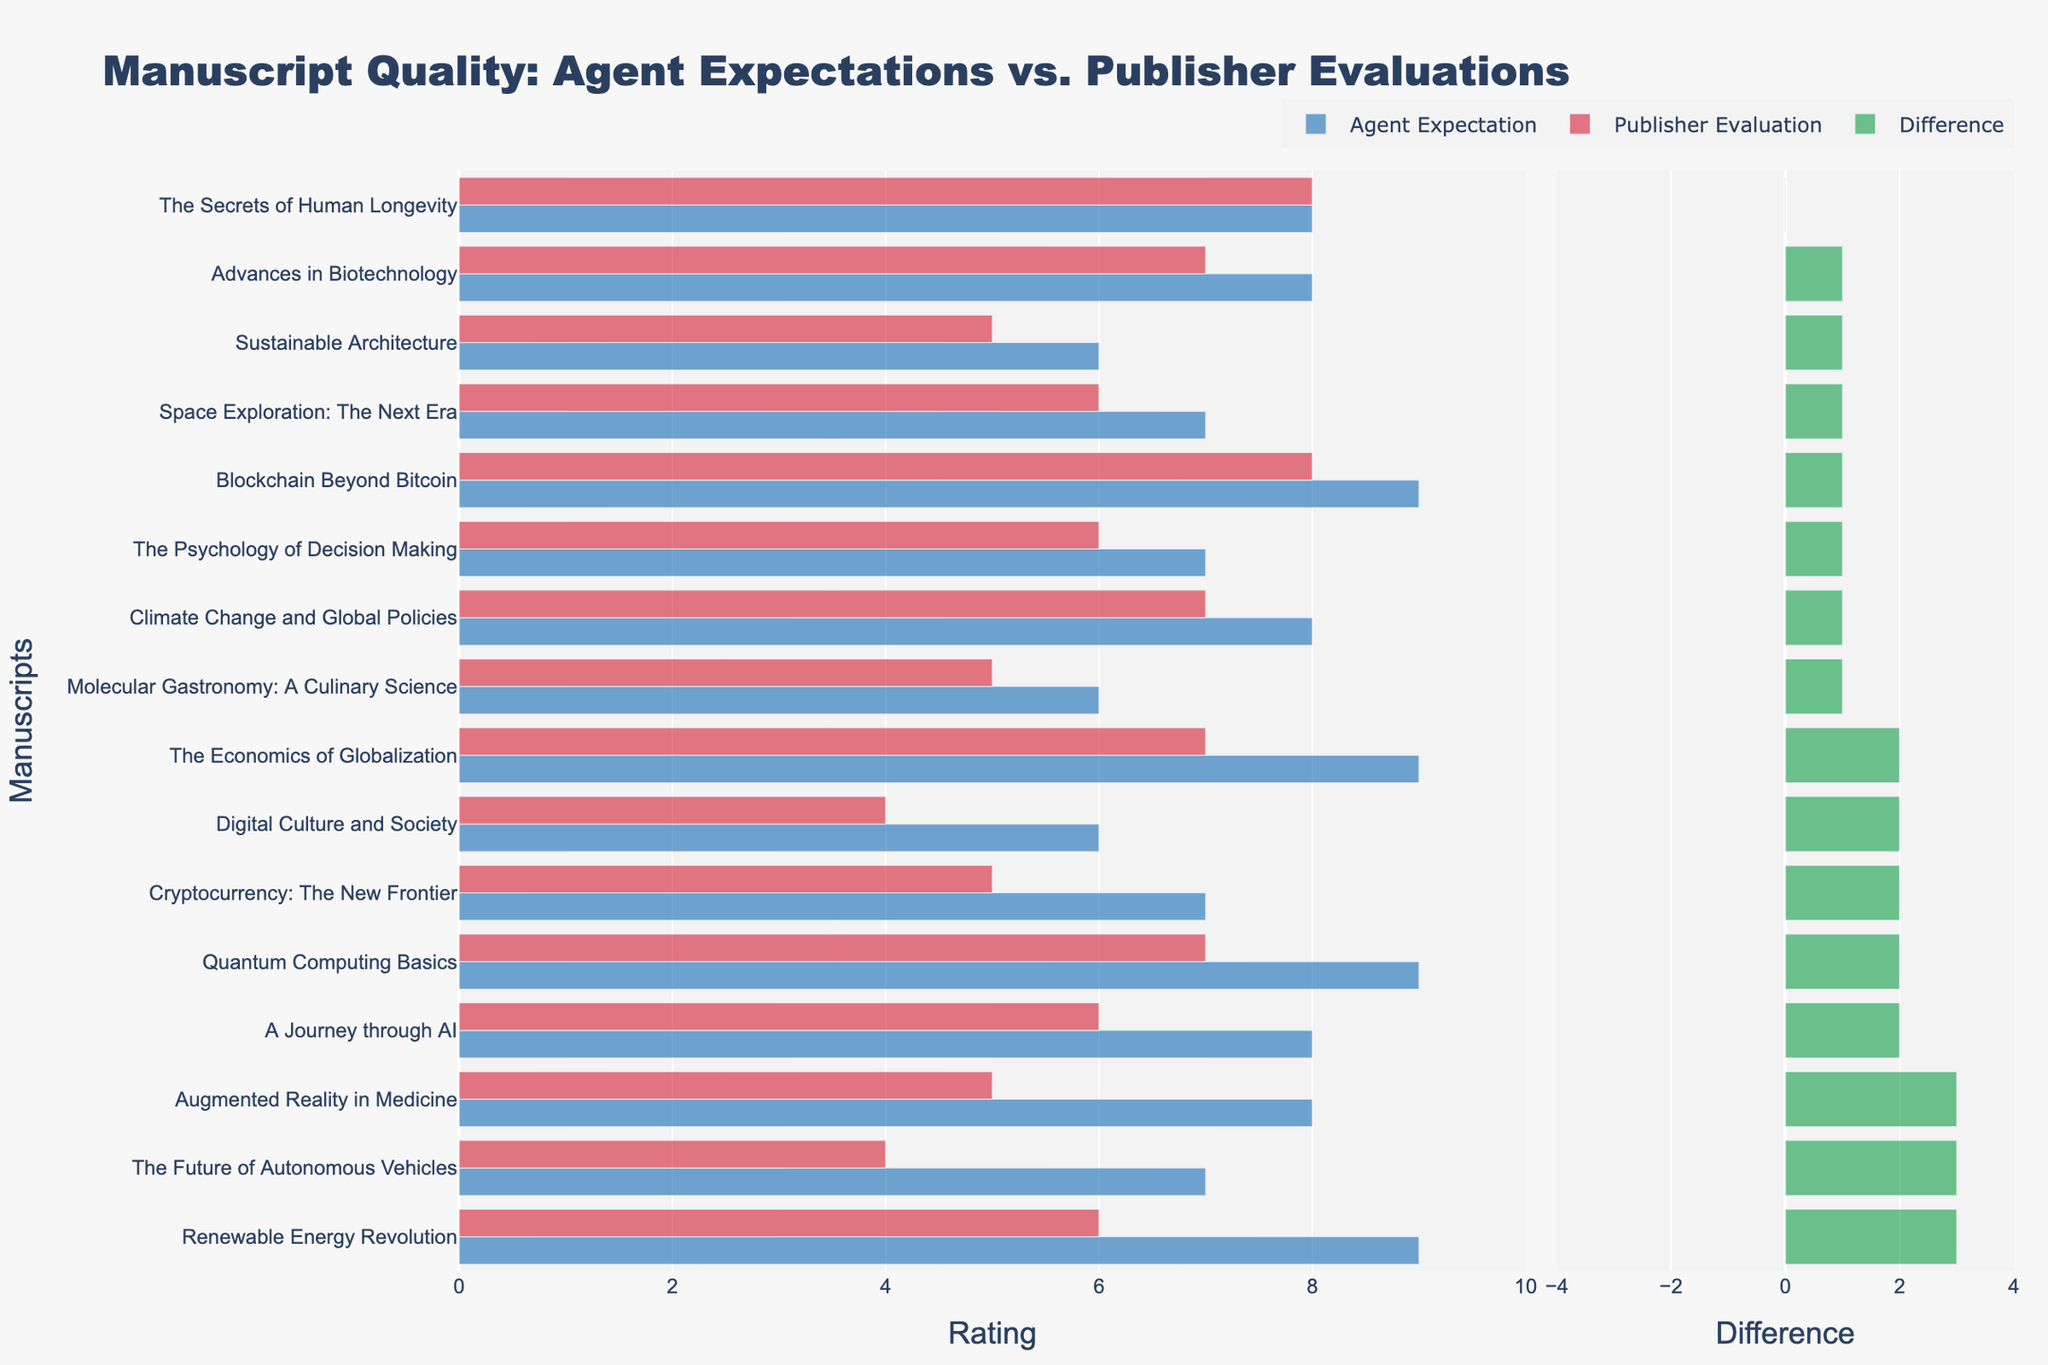What's the difference between the Agent Expectation and Publisher Evaluation for "Renewable Energy Revolution"? Locate the "Renewable Energy Revolution" manuscript on the figure, check the lengths of the bars representing Agent Expectation and Publisher Evaluation. The difference is (9 - 6).
Answer: 3 Which manuscript has the largest discrepancy between Agent Expectation and Publisher Evaluation? Find the manuscript with the longest difference bar (green bar). "The Future of Autonomous Vehicles" shows the largest negative difference.
Answer: "The Future of Autonomous Vehicles" How many manuscripts have Agent Expectations equal to Publisher Evaluations? Look at the figure and count the manuscripts where the blue and red bars have the same length. Only one manuscript, "The Secrets of Human Longevity," has equal ratings.
Answer: 1 Identify the manuscript with the lowest Publisher Evaluation and state its difference from Agent Expectation. Find the shortest red bar (Publisher Evaluation) and note its corresponding green bar (Difference). "Digital Culture and Society" has the lowest Publisher Evaluation, with a difference of (6 - 4).
Answer: "Digital Culture and Society", 2 What is the average Agent Expectation rating for all manuscripts? Sum all the blue bars' lengths (Agent Expectation ratings) and divide by the number of manuscripts. The Agent Expectation ratings sum up to 116 and there are 15 manuscripts. So the average is 116/15 ≈ 7.73.
Answer: 7.73 Which manuscript has the highest Publisher Evaluation and what is its Agent Expectation? Look for the manuscript with the longest red bar (Publisher Evaluation). "The Secrets of Human Longevity" and "Blockchain Beyond Bitcoin" both have a Publisher Evaluation of 8. The corresponding Agent Expectations for these are (8 for "The Secrets of Human Longevity") and (9 for "Blockchain Beyond Bitcoin").
Answer: "The Secrets of Human Longevity" (8), "Blockchain Beyond Bitcoin" (9) For "Augmented Reality in Medicine", is the difference between Agent Expectation and Publisher Evaluation positive or negative? Locate "Augmented Reality in Medicine" and compare the lengths of the blue and red bars. The difference is (8 - 5), which is positive.
Answer: Positive Calculate the total Publisher Evaluation for manuscripts with Agent Expectations of 7. Identify all manuscripts with an Agent Expectation of 7, sum their Publisher Evaluations. For "Cryptocurrency: The New Frontier" (5), "The Future of Autonomous Vehicles" (4), "The Psychology of Decision Making" (6), "Space Exploration: The Next Era" (6). Total is 5 + 4 + 6 + 6 = 21.
Answer: 21 